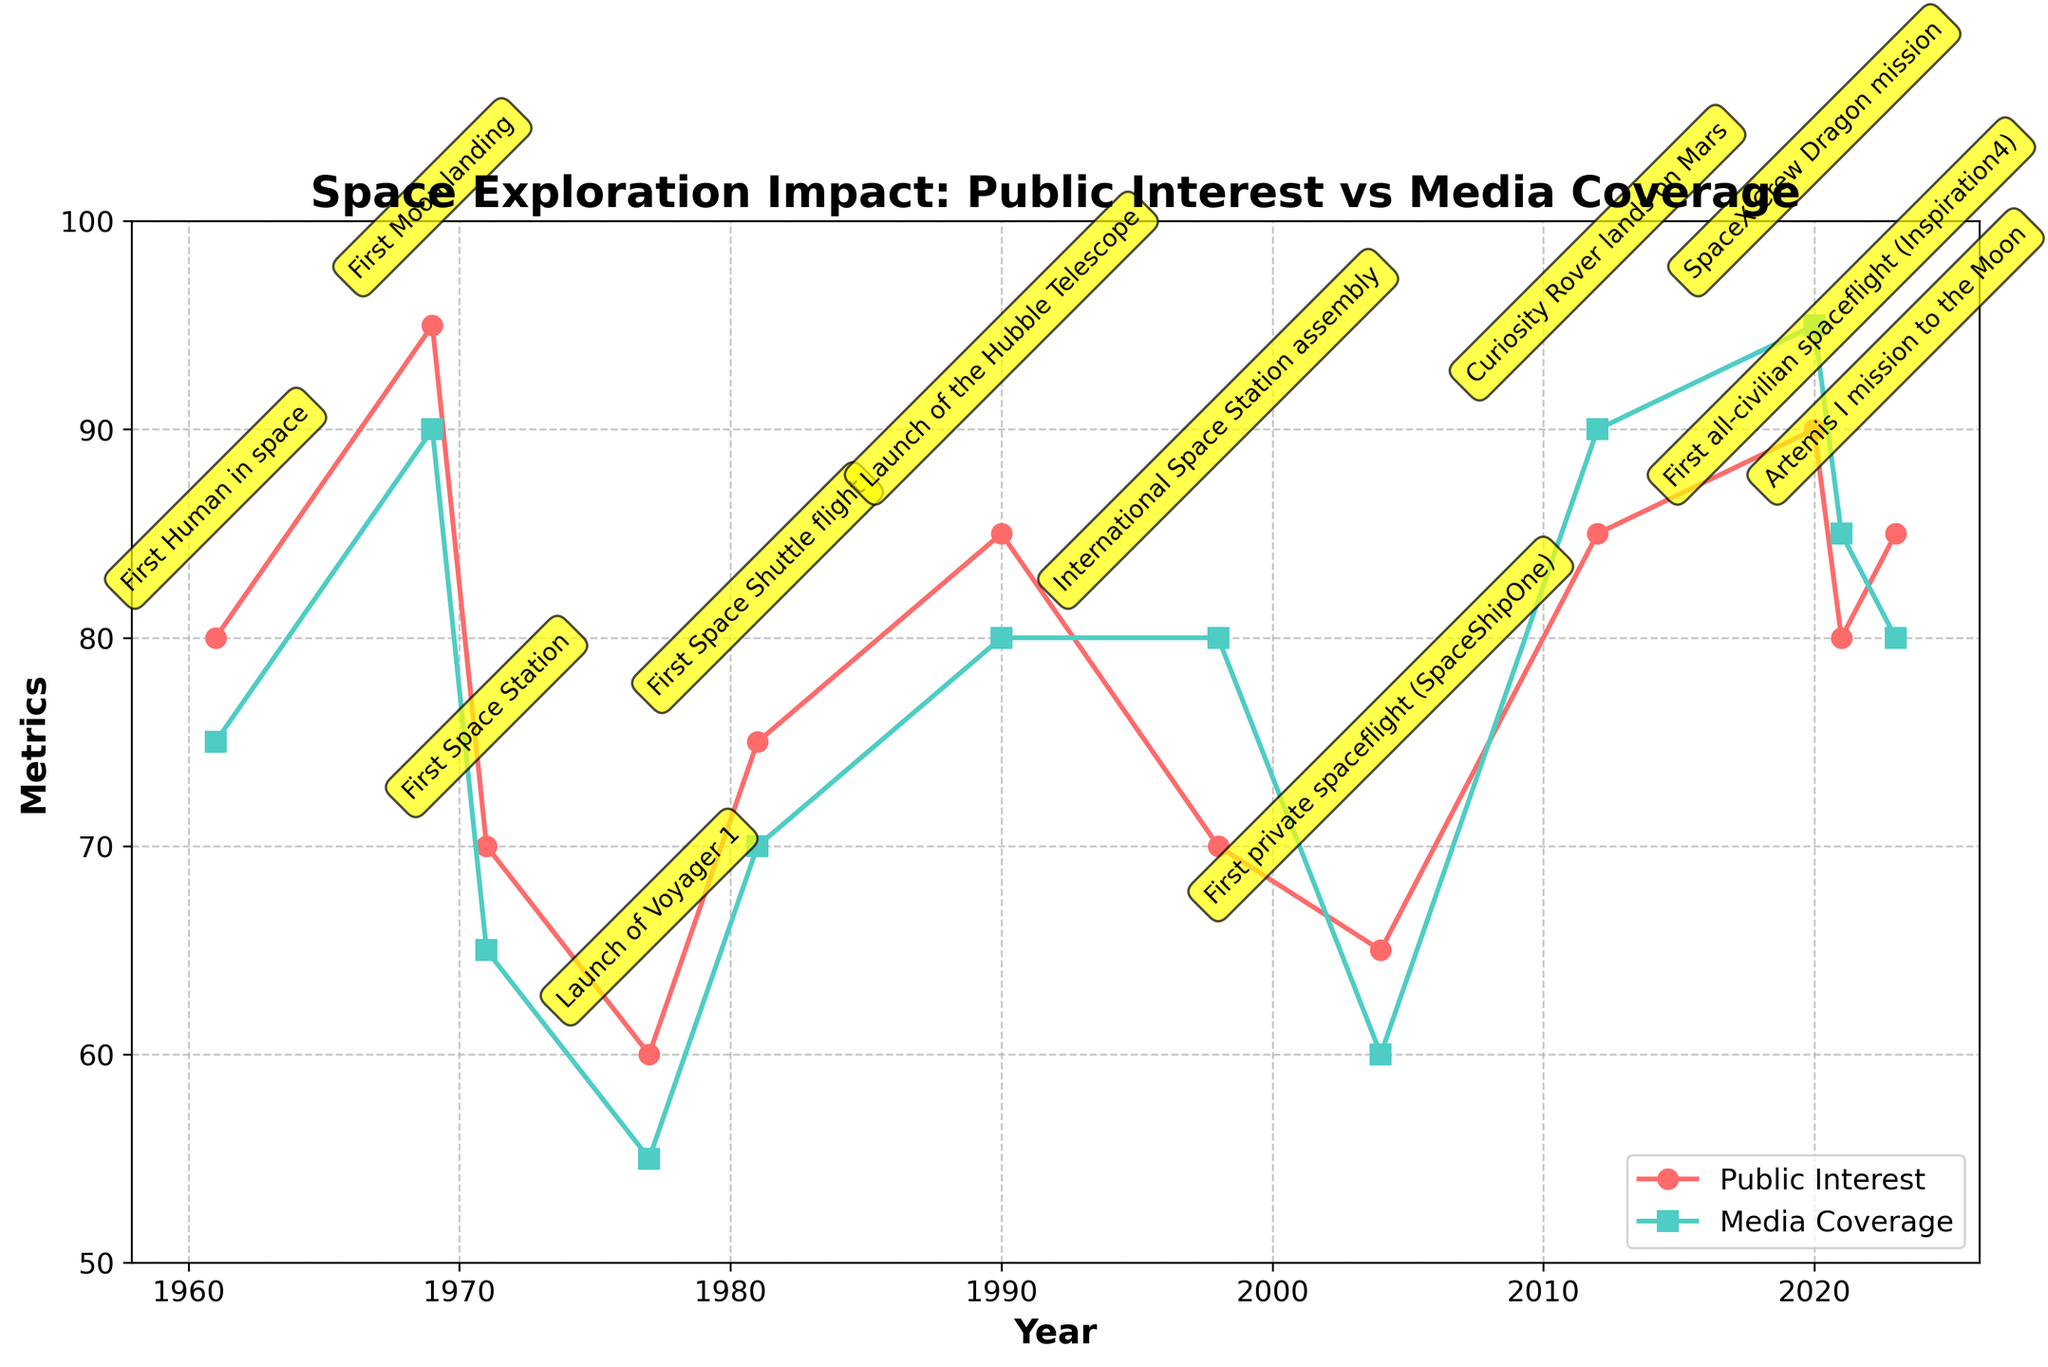what is the title of the plot? The title is located at the top of the plot, above the time series lines, and reads 'Space Exploration Impact: Public Interest vs Media Coverage'.
Answer: Space Exploration Impact: Public Interest vs Media Coverage How many data points are plotted in the figure? The number of data points can be counted by observing the distinct markers along the x-axis (years) for both the 'Public Interest' and 'Media Coverage' lines.
Answer: 12 Which year recorded the highest public interest metric? We can identify this by observing the peaks in the red line (Public Interest) and checking the corresponding year on the x-axis. The highest public interest metric is in 1969.
Answer: 1969 Which space mission corresponds to the year when public interest and media coverage had the most significant combined increase compared to the previous data point? By comparing the difference in metrics between consecutive years for both lines, we observe the significant jumps. The combined increase is seen the most substantial from 2004 to 2012, which corresponds to the Curiosity Rover lands on Mars mission.
Answer: Curiosity Rover lands on Mars For the First Space Shuttle flight, how do the public interest and media coverage metrics compare? Around the year 1981, locate the values on both the red (Public Interest) and teal (Media Coverage) lines. The public interest metric is slightly higher than the media coverage metric.
Answer: Public Interest is higher What are the media coverage metrics for the years 1961 and 2020, and how much have they changed? Check the values of the teal line at 1961 and 2020. Subtract the earlier metric from the later metric. Media Coverage in 1961 is 75 and in 2020 is 95.
Answer: 20 What is the average value of public interest metrics over the plotted period? Sum all the public interest values and divide by the number of years (12). Values: (80+95+70+60+75+85+70+65+85+90+80+85)/12 = 79.58
Answer: 79.58 Which public events have identical public interest and media coverage metrics? Look for years where points on the red and teal lines are at the exact same level. In this plot, it is evident in 1998 (International Space Station assembly).
Answer: International Space Station assembly How did public interest and media coverage metrics trend from the 2004 to 2023 data points? Observing the slope of the lines between these points shows that overall, public interest metrics slightly increased, while media coverage started lower but peaked in 2020 and slightly declined afterward.
Answer: Both increased overall Between the year 1969 and 1990, how did public interest metrics change? Find the public interest metrics at these two points (1969 and 1990). In 1969 it is 95, and in 1990 it is 85. Subtract the latter from the former to get the difference. 95 - 85 equals a decrease.
Answer: Decrease by 10 